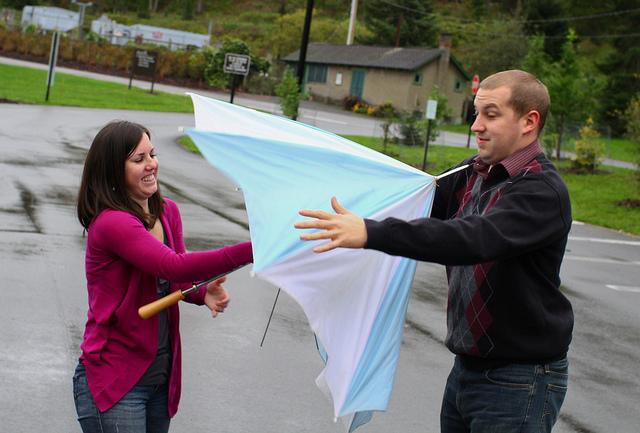How many umbrellas are pictured?
Short answer required. 1. What color is the ladies sweater?
Be succinct. Pink. Who is helping to open the umbrella?
Concise answer only. Man. Are they a couple?
Quick response, please. Yes. 